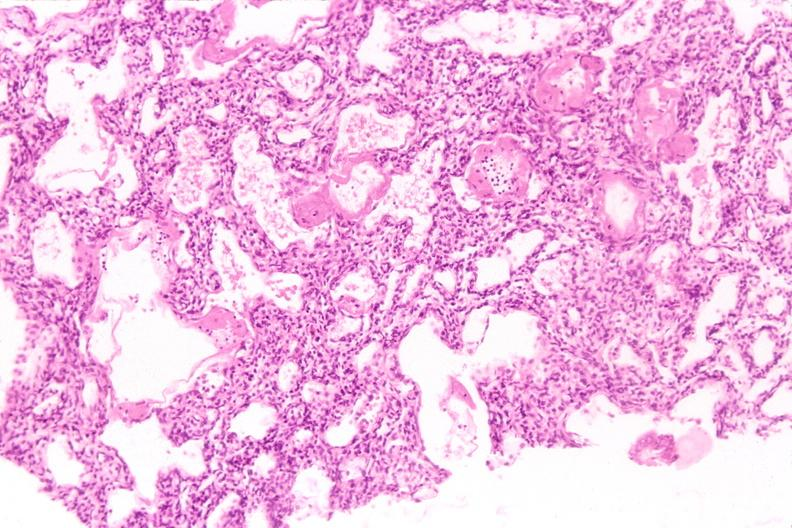where is this?
Answer the question using a single word or phrase. Lung 